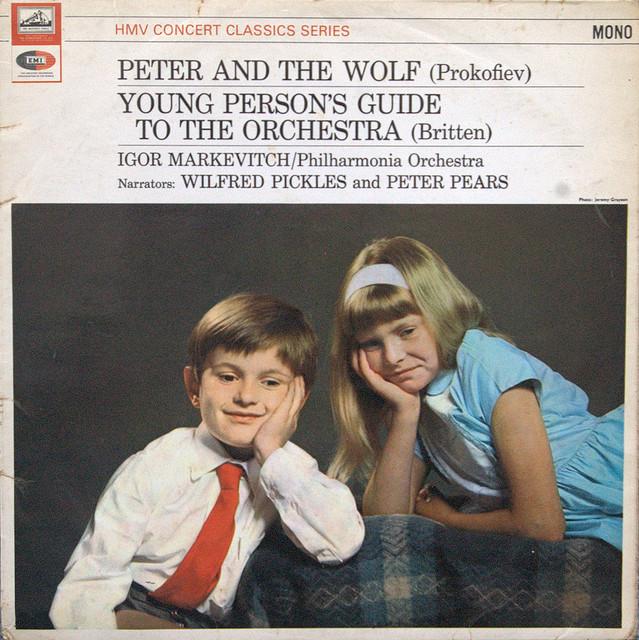Whose concert classic series is this?
Write a very short answer. Hmv. Are they a couple?
Quick response, please. No. What are the kid's looking at?
Keep it brief. Camera. Who are the narrators?
Short answer required. Wilfred pickles and peter pears. Do the people look happy?
Write a very short answer. No. 